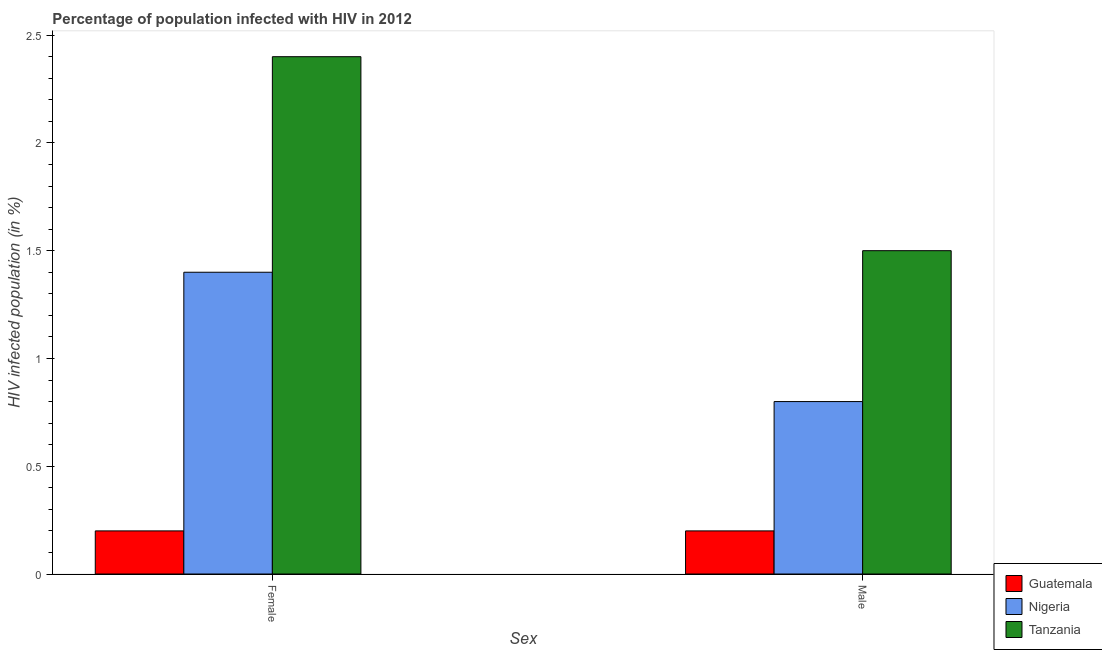Are the number of bars per tick equal to the number of legend labels?
Ensure brevity in your answer.  Yes. Are the number of bars on each tick of the X-axis equal?
Your answer should be compact. Yes. How many bars are there on the 1st tick from the left?
Give a very brief answer. 3. How many bars are there on the 1st tick from the right?
Offer a very short reply. 3. What is the percentage of females who are infected with hiv in Tanzania?
Your answer should be very brief. 2.4. Across all countries, what is the minimum percentage of females who are infected with hiv?
Make the answer very short. 0.2. In which country was the percentage of males who are infected with hiv maximum?
Keep it short and to the point. Tanzania. In which country was the percentage of males who are infected with hiv minimum?
Give a very brief answer. Guatemala. What is the difference between the percentage of males who are infected with hiv in Nigeria and that in Tanzania?
Offer a terse response. -0.7. What is the difference between the percentage of females who are infected with hiv in Guatemala and the percentage of males who are infected with hiv in Nigeria?
Your answer should be compact. -0.6. What is the average percentage of females who are infected with hiv per country?
Your answer should be compact. 1.33. What is the difference between the percentage of females who are infected with hiv and percentage of males who are infected with hiv in Nigeria?
Provide a succinct answer. 0.6. What is the ratio of the percentage of females who are infected with hiv in Tanzania to that in Guatemala?
Keep it short and to the point. 12. Is the percentage of females who are infected with hiv in Guatemala less than that in Tanzania?
Ensure brevity in your answer.  Yes. In how many countries, is the percentage of males who are infected with hiv greater than the average percentage of males who are infected with hiv taken over all countries?
Your response must be concise. 1. What does the 2nd bar from the left in Female represents?
Make the answer very short. Nigeria. What does the 2nd bar from the right in Female represents?
Provide a short and direct response. Nigeria. How many countries are there in the graph?
Provide a short and direct response. 3. What is the difference between two consecutive major ticks on the Y-axis?
Your answer should be very brief. 0.5. Does the graph contain any zero values?
Provide a succinct answer. No. Does the graph contain grids?
Offer a very short reply. No. What is the title of the graph?
Provide a short and direct response. Percentage of population infected with HIV in 2012. Does "India" appear as one of the legend labels in the graph?
Offer a terse response. No. What is the label or title of the X-axis?
Your answer should be compact. Sex. What is the label or title of the Y-axis?
Keep it short and to the point. HIV infected population (in %). What is the HIV infected population (in %) of Guatemala in Female?
Make the answer very short. 0.2. What is the HIV infected population (in %) in Tanzania in Female?
Make the answer very short. 2.4. Across all Sex, what is the maximum HIV infected population (in %) of Guatemala?
Provide a succinct answer. 0.2. Across all Sex, what is the minimum HIV infected population (in %) of Nigeria?
Your answer should be compact. 0.8. What is the total HIV infected population (in %) of Tanzania in the graph?
Provide a succinct answer. 3.9. What is the difference between the HIV infected population (in %) in Nigeria in Female and that in Male?
Your answer should be very brief. 0.6. What is the difference between the HIV infected population (in %) of Tanzania in Female and that in Male?
Offer a very short reply. 0.9. What is the difference between the HIV infected population (in %) of Guatemala in Female and the HIV infected population (in %) of Nigeria in Male?
Offer a terse response. -0.6. What is the difference between the HIV infected population (in %) in Guatemala in Female and the HIV infected population (in %) in Tanzania in Male?
Ensure brevity in your answer.  -1.3. What is the average HIV infected population (in %) of Guatemala per Sex?
Ensure brevity in your answer.  0.2. What is the average HIV infected population (in %) in Tanzania per Sex?
Offer a very short reply. 1.95. What is the difference between the HIV infected population (in %) in Guatemala and HIV infected population (in %) in Nigeria in Female?
Your answer should be compact. -1.2. What is the difference between the highest and the second highest HIV infected population (in %) of Guatemala?
Make the answer very short. 0. What is the difference between the highest and the lowest HIV infected population (in %) of Guatemala?
Provide a short and direct response. 0. 